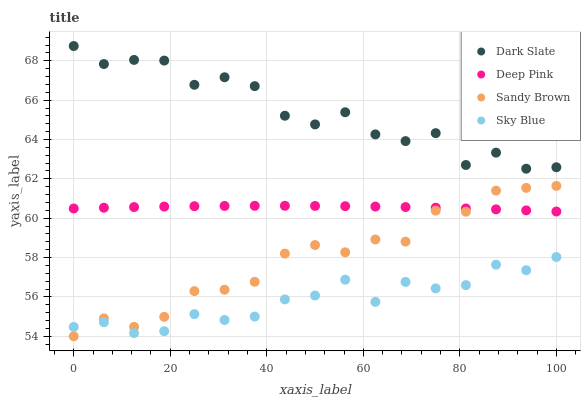Does Sky Blue have the minimum area under the curve?
Answer yes or no. Yes. Does Dark Slate have the maximum area under the curve?
Answer yes or no. Yes. Does Deep Pink have the minimum area under the curve?
Answer yes or no. No. Does Deep Pink have the maximum area under the curve?
Answer yes or no. No. Is Deep Pink the smoothest?
Answer yes or no. Yes. Is Dark Slate the roughest?
Answer yes or no. Yes. Is Sandy Brown the smoothest?
Answer yes or no. No. Is Sandy Brown the roughest?
Answer yes or no. No. Does Sandy Brown have the lowest value?
Answer yes or no. Yes. Does Deep Pink have the lowest value?
Answer yes or no. No. Does Dark Slate have the highest value?
Answer yes or no. Yes. Does Deep Pink have the highest value?
Answer yes or no. No. Is Deep Pink less than Dark Slate?
Answer yes or no. Yes. Is Dark Slate greater than Deep Pink?
Answer yes or no. Yes. Does Deep Pink intersect Sandy Brown?
Answer yes or no. Yes. Is Deep Pink less than Sandy Brown?
Answer yes or no. No. Is Deep Pink greater than Sandy Brown?
Answer yes or no. No. Does Deep Pink intersect Dark Slate?
Answer yes or no. No. 